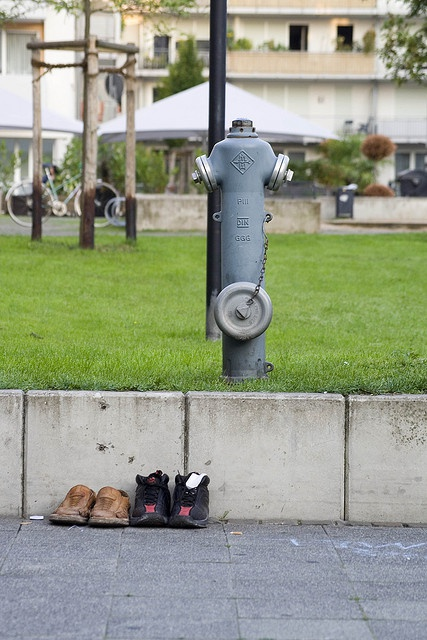Describe the objects in this image and their specific colors. I can see fire hydrant in lightgray, darkgray, gray, and black tones and bicycle in lightgray, darkgray, gray, and black tones in this image. 